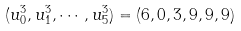<formula> <loc_0><loc_0><loc_500><loc_500>( u ^ { 3 } _ { 0 } , u ^ { 3 } _ { 1 } , \cdots , u ^ { 3 } _ { 5 } ) = ( 6 , 0 , 3 , 9 , 9 , 9 )</formula> 